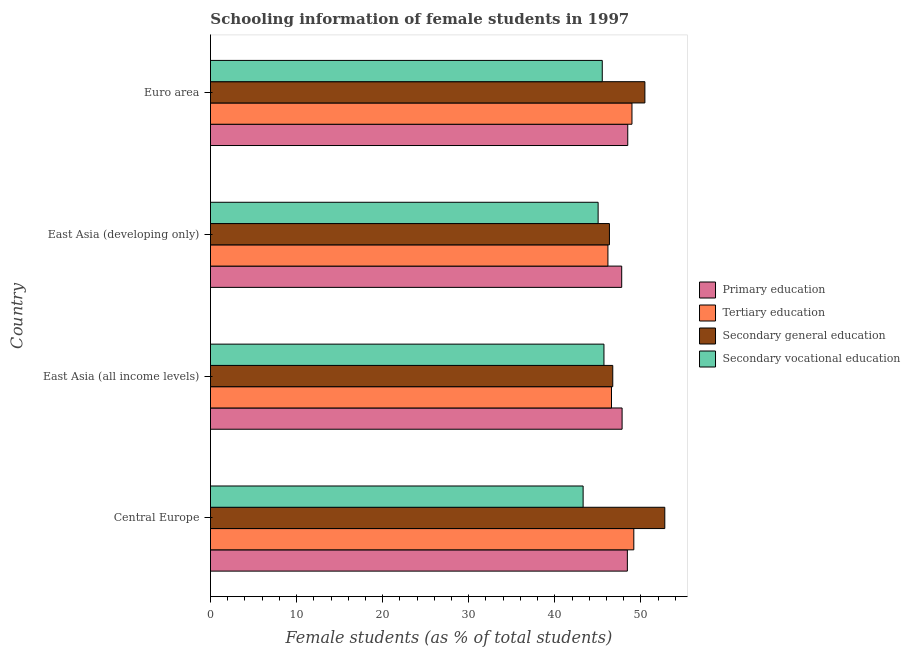How many groups of bars are there?
Make the answer very short. 4. Are the number of bars per tick equal to the number of legend labels?
Offer a very short reply. Yes. Are the number of bars on each tick of the Y-axis equal?
Your answer should be very brief. Yes. How many bars are there on the 1st tick from the top?
Your response must be concise. 4. What is the label of the 3rd group of bars from the top?
Your response must be concise. East Asia (all income levels). In how many cases, is the number of bars for a given country not equal to the number of legend labels?
Offer a terse response. 0. What is the percentage of female students in secondary vocational education in Euro area?
Offer a very short reply. 45.51. Across all countries, what is the maximum percentage of female students in tertiary education?
Keep it short and to the point. 49.17. Across all countries, what is the minimum percentage of female students in secondary education?
Offer a very short reply. 46.34. In which country was the percentage of female students in secondary education maximum?
Offer a very short reply. Central Europe. In which country was the percentage of female students in primary education minimum?
Keep it short and to the point. East Asia (developing only). What is the total percentage of female students in tertiary education in the graph?
Your answer should be very brief. 190.86. What is the difference between the percentage of female students in tertiary education in Central Europe and that in East Asia (developing only)?
Offer a very short reply. 3.01. What is the difference between the percentage of female students in secondary education in Euro area and the percentage of female students in secondary vocational education in East Asia (developing only)?
Your answer should be compact. 5.43. What is the average percentage of female students in secondary education per country?
Your answer should be compact. 49.07. What is the difference between the percentage of female students in tertiary education and percentage of female students in primary education in East Asia (developing only)?
Offer a terse response. -1.6. In how many countries, is the percentage of female students in primary education greater than 12 %?
Make the answer very short. 4. What is the ratio of the percentage of female students in secondary education in East Asia (developing only) to that in Euro area?
Make the answer very short. 0.92. Is the percentage of female students in tertiary education in Central Europe less than that in Euro area?
Your answer should be very brief. No. What is the difference between the highest and the second highest percentage of female students in tertiary education?
Your answer should be very brief. 0.21. What is the difference between the highest and the lowest percentage of female students in secondary vocational education?
Offer a terse response. 2.42. Is the sum of the percentage of female students in primary education in Central Europe and East Asia (all income levels) greater than the maximum percentage of female students in secondary vocational education across all countries?
Give a very brief answer. Yes. What does the 2nd bar from the top in East Asia (all income levels) represents?
Your answer should be compact. Secondary general education. What does the 1st bar from the bottom in Euro area represents?
Provide a short and direct response. Primary education. Is it the case that in every country, the sum of the percentage of female students in primary education and percentage of female students in tertiary education is greater than the percentage of female students in secondary education?
Your response must be concise. Yes. What is the difference between two consecutive major ticks on the X-axis?
Provide a short and direct response. 10. Are the values on the major ticks of X-axis written in scientific E-notation?
Make the answer very short. No. What is the title of the graph?
Offer a very short reply. Schooling information of female students in 1997. Does "First 20% of population" appear as one of the legend labels in the graph?
Keep it short and to the point. No. What is the label or title of the X-axis?
Give a very brief answer. Female students (as % of total students). What is the Female students (as % of total students) of Primary education in Central Europe?
Provide a short and direct response. 48.42. What is the Female students (as % of total students) of Tertiary education in Central Europe?
Keep it short and to the point. 49.17. What is the Female students (as % of total students) of Secondary general education in Central Europe?
Keep it short and to the point. 52.77. What is the Female students (as % of total students) in Secondary vocational education in Central Europe?
Ensure brevity in your answer.  43.28. What is the Female students (as % of total students) in Primary education in East Asia (all income levels)?
Offer a terse response. 47.81. What is the Female students (as % of total students) in Tertiary education in East Asia (all income levels)?
Provide a short and direct response. 46.58. What is the Female students (as % of total students) of Secondary general education in East Asia (all income levels)?
Offer a terse response. 46.72. What is the Female students (as % of total students) in Secondary vocational education in East Asia (all income levels)?
Provide a succinct answer. 45.7. What is the Female students (as % of total students) in Primary education in East Asia (developing only)?
Make the answer very short. 47.76. What is the Female students (as % of total students) in Tertiary education in East Asia (developing only)?
Offer a very short reply. 46.16. What is the Female students (as % of total students) of Secondary general education in East Asia (developing only)?
Provide a succinct answer. 46.34. What is the Female students (as % of total students) in Secondary vocational education in East Asia (developing only)?
Your answer should be very brief. 45.02. What is the Female students (as % of total students) in Primary education in Euro area?
Offer a terse response. 48.47. What is the Female students (as % of total students) of Tertiary education in Euro area?
Offer a very short reply. 48.96. What is the Female students (as % of total students) in Secondary general education in Euro area?
Provide a succinct answer. 50.46. What is the Female students (as % of total students) in Secondary vocational education in Euro area?
Your answer should be compact. 45.51. Across all countries, what is the maximum Female students (as % of total students) of Primary education?
Your answer should be compact. 48.47. Across all countries, what is the maximum Female students (as % of total students) of Tertiary education?
Make the answer very short. 49.17. Across all countries, what is the maximum Female students (as % of total students) in Secondary general education?
Provide a succinct answer. 52.77. Across all countries, what is the maximum Female students (as % of total students) of Secondary vocational education?
Ensure brevity in your answer.  45.7. Across all countries, what is the minimum Female students (as % of total students) of Primary education?
Keep it short and to the point. 47.76. Across all countries, what is the minimum Female students (as % of total students) in Tertiary education?
Your response must be concise. 46.16. Across all countries, what is the minimum Female students (as % of total students) of Secondary general education?
Provide a succinct answer. 46.34. Across all countries, what is the minimum Female students (as % of total students) in Secondary vocational education?
Ensure brevity in your answer.  43.28. What is the total Female students (as % of total students) in Primary education in the graph?
Provide a succinct answer. 192.46. What is the total Female students (as % of total students) in Tertiary education in the graph?
Your response must be concise. 190.87. What is the total Female students (as % of total students) in Secondary general education in the graph?
Offer a very short reply. 196.29. What is the total Female students (as % of total students) in Secondary vocational education in the graph?
Your response must be concise. 179.51. What is the difference between the Female students (as % of total students) of Primary education in Central Europe and that in East Asia (all income levels)?
Keep it short and to the point. 0.61. What is the difference between the Female students (as % of total students) of Tertiary education in Central Europe and that in East Asia (all income levels)?
Offer a terse response. 2.59. What is the difference between the Female students (as % of total students) of Secondary general education in Central Europe and that in East Asia (all income levels)?
Your answer should be compact. 6.04. What is the difference between the Female students (as % of total students) in Secondary vocational education in Central Europe and that in East Asia (all income levels)?
Provide a short and direct response. -2.42. What is the difference between the Female students (as % of total students) of Primary education in Central Europe and that in East Asia (developing only)?
Your answer should be compact. 0.66. What is the difference between the Female students (as % of total students) of Tertiary education in Central Europe and that in East Asia (developing only)?
Provide a short and direct response. 3.01. What is the difference between the Female students (as % of total students) in Secondary general education in Central Europe and that in East Asia (developing only)?
Provide a succinct answer. 6.43. What is the difference between the Female students (as % of total students) of Secondary vocational education in Central Europe and that in East Asia (developing only)?
Ensure brevity in your answer.  -1.74. What is the difference between the Female students (as % of total students) in Primary education in Central Europe and that in Euro area?
Make the answer very short. -0.05. What is the difference between the Female students (as % of total students) of Tertiary education in Central Europe and that in Euro area?
Give a very brief answer. 0.21. What is the difference between the Female students (as % of total students) of Secondary general education in Central Europe and that in Euro area?
Your answer should be very brief. 2.31. What is the difference between the Female students (as % of total students) of Secondary vocational education in Central Europe and that in Euro area?
Keep it short and to the point. -2.22. What is the difference between the Female students (as % of total students) of Primary education in East Asia (all income levels) and that in East Asia (developing only)?
Ensure brevity in your answer.  0.04. What is the difference between the Female students (as % of total students) in Tertiary education in East Asia (all income levels) and that in East Asia (developing only)?
Ensure brevity in your answer.  0.42. What is the difference between the Female students (as % of total students) in Secondary general education in East Asia (all income levels) and that in East Asia (developing only)?
Provide a short and direct response. 0.39. What is the difference between the Female students (as % of total students) in Secondary vocational education in East Asia (all income levels) and that in East Asia (developing only)?
Your response must be concise. 0.68. What is the difference between the Female students (as % of total students) in Primary education in East Asia (all income levels) and that in Euro area?
Provide a short and direct response. -0.66. What is the difference between the Female students (as % of total students) in Tertiary education in East Asia (all income levels) and that in Euro area?
Ensure brevity in your answer.  -2.38. What is the difference between the Female students (as % of total students) in Secondary general education in East Asia (all income levels) and that in Euro area?
Make the answer very short. -3.73. What is the difference between the Female students (as % of total students) in Secondary vocational education in East Asia (all income levels) and that in Euro area?
Ensure brevity in your answer.  0.19. What is the difference between the Female students (as % of total students) of Primary education in East Asia (developing only) and that in Euro area?
Your response must be concise. -0.7. What is the difference between the Female students (as % of total students) in Tertiary education in East Asia (developing only) and that in Euro area?
Make the answer very short. -2.79. What is the difference between the Female students (as % of total students) of Secondary general education in East Asia (developing only) and that in Euro area?
Keep it short and to the point. -4.12. What is the difference between the Female students (as % of total students) of Secondary vocational education in East Asia (developing only) and that in Euro area?
Offer a terse response. -0.48. What is the difference between the Female students (as % of total students) in Primary education in Central Europe and the Female students (as % of total students) in Tertiary education in East Asia (all income levels)?
Make the answer very short. 1.84. What is the difference between the Female students (as % of total students) of Primary education in Central Europe and the Female students (as % of total students) of Secondary general education in East Asia (all income levels)?
Offer a very short reply. 1.69. What is the difference between the Female students (as % of total students) of Primary education in Central Europe and the Female students (as % of total students) of Secondary vocational education in East Asia (all income levels)?
Provide a succinct answer. 2.72. What is the difference between the Female students (as % of total students) of Tertiary education in Central Europe and the Female students (as % of total students) of Secondary general education in East Asia (all income levels)?
Provide a short and direct response. 2.44. What is the difference between the Female students (as % of total students) of Tertiary education in Central Europe and the Female students (as % of total students) of Secondary vocational education in East Asia (all income levels)?
Your answer should be compact. 3.47. What is the difference between the Female students (as % of total students) of Secondary general education in Central Europe and the Female students (as % of total students) of Secondary vocational education in East Asia (all income levels)?
Ensure brevity in your answer.  7.07. What is the difference between the Female students (as % of total students) of Primary education in Central Europe and the Female students (as % of total students) of Tertiary education in East Asia (developing only)?
Your answer should be very brief. 2.26. What is the difference between the Female students (as % of total students) of Primary education in Central Europe and the Female students (as % of total students) of Secondary general education in East Asia (developing only)?
Provide a short and direct response. 2.08. What is the difference between the Female students (as % of total students) of Primary education in Central Europe and the Female students (as % of total students) of Secondary vocational education in East Asia (developing only)?
Make the answer very short. 3.4. What is the difference between the Female students (as % of total students) of Tertiary education in Central Europe and the Female students (as % of total students) of Secondary general education in East Asia (developing only)?
Keep it short and to the point. 2.83. What is the difference between the Female students (as % of total students) of Tertiary education in Central Europe and the Female students (as % of total students) of Secondary vocational education in East Asia (developing only)?
Provide a short and direct response. 4.14. What is the difference between the Female students (as % of total students) in Secondary general education in Central Europe and the Female students (as % of total students) in Secondary vocational education in East Asia (developing only)?
Keep it short and to the point. 7.74. What is the difference between the Female students (as % of total students) of Primary education in Central Europe and the Female students (as % of total students) of Tertiary education in Euro area?
Give a very brief answer. -0.54. What is the difference between the Female students (as % of total students) in Primary education in Central Europe and the Female students (as % of total students) in Secondary general education in Euro area?
Your answer should be compact. -2.04. What is the difference between the Female students (as % of total students) of Primary education in Central Europe and the Female students (as % of total students) of Secondary vocational education in Euro area?
Offer a very short reply. 2.91. What is the difference between the Female students (as % of total students) in Tertiary education in Central Europe and the Female students (as % of total students) in Secondary general education in Euro area?
Ensure brevity in your answer.  -1.29. What is the difference between the Female students (as % of total students) in Tertiary education in Central Europe and the Female students (as % of total students) in Secondary vocational education in Euro area?
Provide a succinct answer. 3.66. What is the difference between the Female students (as % of total students) in Secondary general education in Central Europe and the Female students (as % of total students) in Secondary vocational education in Euro area?
Make the answer very short. 7.26. What is the difference between the Female students (as % of total students) of Primary education in East Asia (all income levels) and the Female students (as % of total students) of Tertiary education in East Asia (developing only)?
Keep it short and to the point. 1.65. What is the difference between the Female students (as % of total students) in Primary education in East Asia (all income levels) and the Female students (as % of total students) in Secondary general education in East Asia (developing only)?
Ensure brevity in your answer.  1.47. What is the difference between the Female students (as % of total students) in Primary education in East Asia (all income levels) and the Female students (as % of total students) in Secondary vocational education in East Asia (developing only)?
Ensure brevity in your answer.  2.78. What is the difference between the Female students (as % of total students) in Tertiary education in East Asia (all income levels) and the Female students (as % of total students) in Secondary general education in East Asia (developing only)?
Offer a terse response. 0.24. What is the difference between the Female students (as % of total students) in Tertiary education in East Asia (all income levels) and the Female students (as % of total students) in Secondary vocational education in East Asia (developing only)?
Offer a terse response. 1.55. What is the difference between the Female students (as % of total students) in Secondary general education in East Asia (all income levels) and the Female students (as % of total students) in Secondary vocational education in East Asia (developing only)?
Keep it short and to the point. 1.7. What is the difference between the Female students (as % of total students) of Primary education in East Asia (all income levels) and the Female students (as % of total students) of Tertiary education in Euro area?
Offer a very short reply. -1.15. What is the difference between the Female students (as % of total students) in Primary education in East Asia (all income levels) and the Female students (as % of total students) in Secondary general education in Euro area?
Your answer should be compact. -2.65. What is the difference between the Female students (as % of total students) in Primary education in East Asia (all income levels) and the Female students (as % of total students) in Secondary vocational education in Euro area?
Provide a succinct answer. 2.3. What is the difference between the Female students (as % of total students) in Tertiary education in East Asia (all income levels) and the Female students (as % of total students) in Secondary general education in Euro area?
Give a very brief answer. -3.88. What is the difference between the Female students (as % of total students) in Tertiary education in East Asia (all income levels) and the Female students (as % of total students) in Secondary vocational education in Euro area?
Your answer should be compact. 1.07. What is the difference between the Female students (as % of total students) in Secondary general education in East Asia (all income levels) and the Female students (as % of total students) in Secondary vocational education in Euro area?
Provide a succinct answer. 1.22. What is the difference between the Female students (as % of total students) in Primary education in East Asia (developing only) and the Female students (as % of total students) in Tertiary education in Euro area?
Offer a very short reply. -1.19. What is the difference between the Female students (as % of total students) of Primary education in East Asia (developing only) and the Female students (as % of total students) of Secondary general education in Euro area?
Ensure brevity in your answer.  -2.69. What is the difference between the Female students (as % of total students) of Primary education in East Asia (developing only) and the Female students (as % of total students) of Secondary vocational education in Euro area?
Keep it short and to the point. 2.26. What is the difference between the Female students (as % of total students) of Tertiary education in East Asia (developing only) and the Female students (as % of total students) of Secondary general education in Euro area?
Your answer should be compact. -4.29. What is the difference between the Female students (as % of total students) in Tertiary education in East Asia (developing only) and the Female students (as % of total students) in Secondary vocational education in Euro area?
Give a very brief answer. 0.66. What is the difference between the Female students (as % of total students) in Secondary general education in East Asia (developing only) and the Female students (as % of total students) in Secondary vocational education in Euro area?
Your response must be concise. 0.83. What is the average Female students (as % of total students) in Primary education per country?
Offer a very short reply. 48.11. What is the average Female students (as % of total students) of Tertiary education per country?
Offer a terse response. 47.72. What is the average Female students (as % of total students) in Secondary general education per country?
Your answer should be very brief. 49.07. What is the average Female students (as % of total students) of Secondary vocational education per country?
Offer a very short reply. 44.88. What is the difference between the Female students (as % of total students) in Primary education and Female students (as % of total students) in Tertiary education in Central Europe?
Offer a very short reply. -0.75. What is the difference between the Female students (as % of total students) in Primary education and Female students (as % of total students) in Secondary general education in Central Europe?
Offer a terse response. -4.35. What is the difference between the Female students (as % of total students) of Primary education and Female students (as % of total students) of Secondary vocational education in Central Europe?
Your answer should be very brief. 5.14. What is the difference between the Female students (as % of total students) in Tertiary education and Female students (as % of total students) in Secondary general education in Central Europe?
Provide a short and direct response. -3.6. What is the difference between the Female students (as % of total students) of Tertiary education and Female students (as % of total students) of Secondary vocational education in Central Europe?
Give a very brief answer. 5.89. What is the difference between the Female students (as % of total students) in Secondary general education and Female students (as % of total students) in Secondary vocational education in Central Europe?
Offer a very short reply. 9.49. What is the difference between the Female students (as % of total students) in Primary education and Female students (as % of total students) in Tertiary education in East Asia (all income levels)?
Offer a very short reply. 1.23. What is the difference between the Female students (as % of total students) in Primary education and Female students (as % of total students) in Secondary general education in East Asia (all income levels)?
Make the answer very short. 1.08. What is the difference between the Female students (as % of total students) of Primary education and Female students (as % of total students) of Secondary vocational education in East Asia (all income levels)?
Ensure brevity in your answer.  2.11. What is the difference between the Female students (as % of total students) of Tertiary education and Female students (as % of total students) of Secondary general education in East Asia (all income levels)?
Offer a very short reply. -0.15. What is the difference between the Female students (as % of total students) in Tertiary education and Female students (as % of total students) in Secondary vocational education in East Asia (all income levels)?
Ensure brevity in your answer.  0.88. What is the difference between the Female students (as % of total students) in Secondary general education and Female students (as % of total students) in Secondary vocational education in East Asia (all income levels)?
Make the answer very short. 1.02. What is the difference between the Female students (as % of total students) of Primary education and Female students (as % of total students) of Tertiary education in East Asia (developing only)?
Provide a short and direct response. 1.6. What is the difference between the Female students (as % of total students) of Primary education and Female students (as % of total students) of Secondary general education in East Asia (developing only)?
Make the answer very short. 1.43. What is the difference between the Female students (as % of total students) in Primary education and Female students (as % of total students) in Secondary vocational education in East Asia (developing only)?
Keep it short and to the point. 2.74. What is the difference between the Female students (as % of total students) of Tertiary education and Female students (as % of total students) of Secondary general education in East Asia (developing only)?
Offer a very short reply. -0.18. What is the difference between the Female students (as % of total students) in Tertiary education and Female students (as % of total students) in Secondary vocational education in East Asia (developing only)?
Offer a very short reply. 1.14. What is the difference between the Female students (as % of total students) of Secondary general education and Female students (as % of total students) of Secondary vocational education in East Asia (developing only)?
Offer a terse response. 1.31. What is the difference between the Female students (as % of total students) of Primary education and Female students (as % of total students) of Tertiary education in Euro area?
Your answer should be very brief. -0.49. What is the difference between the Female students (as % of total students) of Primary education and Female students (as % of total students) of Secondary general education in Euro area?
Your answer should be very brief. -1.99. What is the difference between the Female students (as % of total students) of Primary education and Female students (as % of total students) of Secondary vocational education in Euro area?
Ensure brevity in your answer.  2.96. What is the difference between the Female students (as % of total students) of Tertiary education and Female students (as % of total students) of Secondary general education in Euro area?
Offer a terse response. -1.5. What is the difference between the Female students (as % of total students) of Tertiary education and Female students (as % of total students) of Secondary vocational education in Euro area?
Provide a succinct answer. 3.45. What is the difference between the Female students (as % of total students) in Secondary general education and Female students (as % of total students) in Secondary vocational education in Euro area?
Provide a succinct answer. 4.95. What is the ratio of the Female students (as % of total students) in Primary education in Central Europe to that in East Asia (all income levels)?
Offer a terse response. 1.01. What is the ratio of the Female students (as % of total students) of Tertiary education in Central Europe to that in East Asia (all income levels)?
Keep it short and to the point. 1.06. What is the ratio of the Female students (as % of total students) in Secondary general education in Central Europe to that in East Asia (all income levels)?
Ensure brevity in your answer.  1.13. What is the ratio of the Female students (as % of total students) in Secondary vocational education in Central Europe to that in East Asia (all income levels)?
Make the answer very short. 0.95. What is the ratio of the Female students (as % of total students) in Primary education in Central Europe to that in East Asia (developing only)?
Provide a succinct answer. 1.01. What is the ratio of the Female students (as % of total students) in Tertiary education in Central Europe to that in East Asia (developing only)?
Your answer should be very brief. 1.07. What is the ratio of the Female students (as % of total students) in Secondary general education in Central Europe to that in East Asia (developing only)?
Your response must be concise. 1.14. What is the ratio of the Female students (as % of total students) of Secondary vocational education in Central Europe to that in East Asia (developing only)?
Keep it short and to the point. 0.96. What is the ratio of the Female students (as % of total students) in Secondary general education in Central Europe to that in Euro area?
Provide a short and direct response. 1.05. What is the ratio of the Female students (as % of total students) in Secondary vocational education in Central Europe to that in Euro area?
Offer a terse response. 0.95. What is the ratio of the Female students (as % of total students) of Secondary general education in East Asia (all income levels) to that in East Asia (developing only)?
Keep it short and to the point. 1.01. What is the ratio of the Female students (as % of total students) of Secondary vocational education in East Asia (all income levels) to that in East Asia (developing only)?
Ensure brevity in your answer.  1.01. What is the ratio of the Female students (as % of total students) of Primary education in East Asia (all income levels) to that in Euro area?
Offer a terse response. 0.99. What is the ratio of the Female students (as % of total students) of Tertiary education in East Asia (all income levels) to that in Euro area?
Give a very brief answer. 0.95. What is the ratio of the Female students (as % of total students) in Secondary general education in East Asia (all income levels) to that in Euro area?
Offer a terse response. 0.93. What is the ratio of the Female students (as % of total students) in Secondary vocational education in East Asia (all income levels) to that in Euro area?
Your response must be concise. 1. What is the ratio of the Female students (as % of total students) of Primary education in East Asia (developing only) to that in Euro area?
Provide a succinct answer. 0.99. What is the ratio of the Female students (as % of total students) of Tertiary education in East Asia (developing only) to that in Euro area?
Ensure brevity in your answer.  0.94. What is the ratio of the Female students (as % of total students) of Secondary general education in East Asia (developing only) to that in Euro area?
Your answer should be compact. 0.92. What is the difference between the highest and the second highest Female students (as % of total students) of Primary education?
Make the answer very short. 0.05. What is the difference between the highest and the second highest Female students (as % of total students) in Tertiary education?
Give a very brief answer. 0.21. What is the difference between the highest and the second highest Female students (as % of total students) of Secondary general education?
Provide a succinct answer. 2.31. What is the difference between the highest and the second highest Female students (as % of total students) in Secondary vocational education?
Offer a terse response. 0.19. What is the difference between the highest and the lowest Female students (as % of total students) of Primary education?
Keep it short and to the point. 0.7. What is the difference between the highest and the lowest Female students (as % of total students) in Tertiary education?
Make the answer very short. 3.01. What is the difference between the highest and the lowest Female students (as % of total students) of Secondary general education?
Keep it short and to the point. 6.43. What is the difference between the highest and the lowest Female students (as % of total students) in Secondary vocational education?
Make the answer very short. 2.42. 